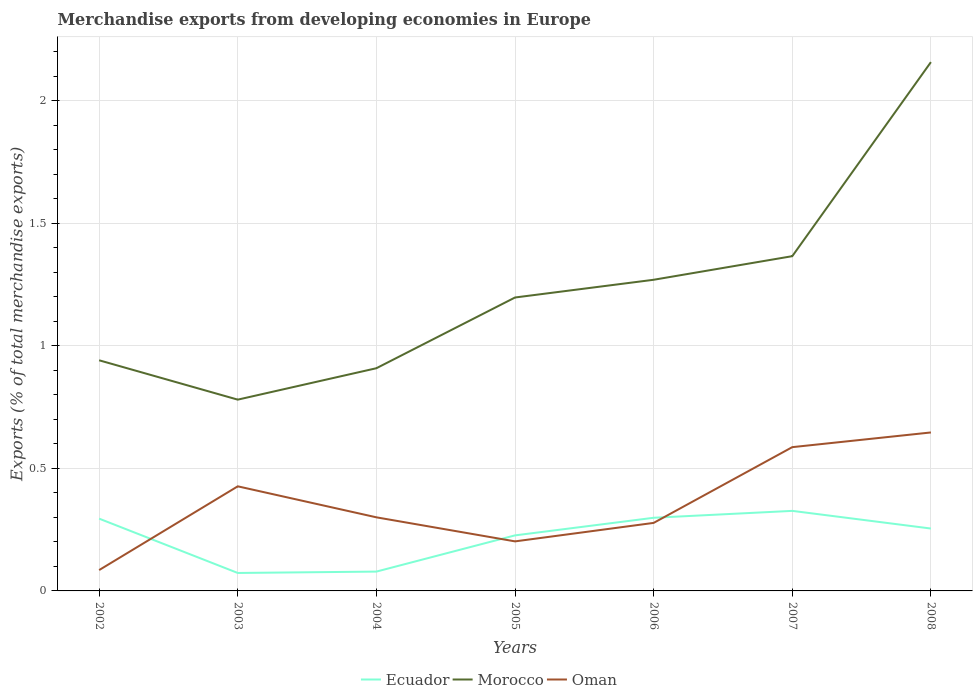Is the number of lines equal to the number of legend labels?
Offer a very short reply. Yes. Across all years, what is the maximum percentage of total merchandise exports in Morocco?
Give a very brief answer. 0.78. In which year was the percentage of total merchandise exports in Oman maximum?
Keep it short and to the point. 2002. What is the total percentage of total merchandise exports in Oman in the graph?
Offer a very short reply. -0.16. What is the difference between the highest and the second highest percentage of total merchandise exports in Morocco?
Make the answer very short. 1.38. What is the difference between the highest and the lowest percentage of total merchandise exports in Morocco?
Give a very brief answer. 3. Is the percentage of total merchandise exports in Ecuador strictly greater than the percentage of total merchandise exports in Morocco over the years?
Provide a short and direct response. Yes. Does the graph contain any zero values?
Offer a terse response. No. Does the graph contain grids?
Your answer should be very brief. Yes. How many legend labels are there?
Make the answer very short. 3. How are the legend labels stacked?
Offer a very short reply. Horizontal. What is the title of the graph?
Provide a short and direct response. Merchandise exports from developing economies in Europe. Does "Libya" appear as one of the legend labels in the graph?
Offer a very short reply. No. What is the label or title of the Y-axis?
Provide a short and direct response. Exports (% of total merchandise exports). What is the Exports (% of total merchandise exports) in Ecuador in 2002?
Provide a short and direct response. 0.3. What is the Exports (% of total merchandise exports) of Morocco in 2002?
Provide a short and direct response. 0.94. What is the Exports (% of total merchandise exports) in Oman in 2002?
Ensure brevity in your answer.  0.09. What is the Exports (% of total merchandise exports) in Ecuador in 2003?
Provide a succinct answer. 0.07. What is the Exports (% of total merchandise exports) in Morocco in 2003?
Your answer should be compact. 0.78. What is the Exports (% of total merchandise exports) in Oman in 2003?
Keep it short and to the point. 0.43. What is the Exports (% of total merchandise exports) of Ecuador in 2004?
Keep it short and to the point. 0.08. What is the Exports (% of total merchandise exports) in Morocco in 2004?
Provide a short and direct response. 0.91. What is the Exports (% of total merchandise exports) of Oman in 2004?
Offer a terse response. 0.3. What is the Exports (% of total merchandise exports) in Ecuador in 2005?
Provide a short and direct response. 0.23. What is the Exports (% of total merchandise exports) of Morocco in 2005?
Make the answer very short. 1.2. What is the Exports (% of total merchandise exports) in Oman in 2005?
Your response must be concise. 0.2. What is the Exports (% of total merchandise exports) of Ecuador in 2006?
Keep it short and to the point. 0.3. What is the Exports (% of total merchandise exports) in Morocco in 2006?
Provide a short and direct response. 1.27. What is the Exports (% of total merchandise exports) in Oman in 2006?
Make the answer very short. 0.28. What is the Exports (% of total merchandise exports) of Ecuador in 2007?
Make the answer very short. 0.33. What is the Exports (% of total merchandise exports) of Morocco in 2007?
Keep it short and to the point. 1.37. What is the Exports (% of total merchandise exports) of Oman in 2007?
Ensure brevity in your answer.  0.59. What is the Exports (% of total merchandise exports) in Ecuador in 2008?
Offer a very short reply. 0.25. What is the Exports (% of total merchandise exports) of Morocco in 2008?
Offer a very short reply. 2.16. What is the Exports (% of total merchandise exports) of Oman in 2008?
Give a very brief answer. 0.65. Across all years, what is the maximum Exports (% of total merchandise exports) in Ecuador?
Offer a very short reply. 0.33. Across all years, what is the maximum Exports (% of total merchandise exports) in Morocco?
Ensure brevity in your answer.  2.16. Across all years, what is the maximum Exports (% of total merchandise exports) in Oman?
Offer a terse response. 0.65. Across all years, what is the minimum Exports (% of total merchandise exports) of Ecuador?
Ensure brevity in your answer.  0.07. Across all years, what is the minimum Exports (% of total merchandise exports) in Morocco?
Give a very brief answer. 0.78. Across all years, what is the minimum Exports (% of total merchandise exports) of Oman?
Your answer should be compact. 0.09. What is the total Exports (% of total merchandise exports) of Ecuador in the graph?
Provide a succinct answer. 1.55. What is the total Exports (% of total merchandise exports) of Morocco in the graph?
Offer a terse response. 8.62. What is the total Exports (% of total merchandise exports) of Oman in the graph?
Provide a short and direct response. 2.53. What is the difference between the Exports (% of total merchandise exports) of Ecuador in 2002 and that in 2003?
Offer a very short reply. 0.22. What is the difference between the Exports (% of total merchandise exports) in Morocco in 2002 and that in 2003?
Provide a succinct answer. 0.16. What is the difference between the Exports (% of total merchandise exports) in Oman in 2002 and that in 2003?
Keep it short and to the point. -0.34. What is the difference between the Exports (% of total merchandise exports) of Ecuador in 2002 and that in 2004?
Ensure brevity in your answer.  0.22. What is the difference between the Exports (% of total merchandise exports) in Morocco in 2002 and that in 2004?
Make the answer very short. 0.03. What is the difference between the Exports (% of total merchandise exports) of Oman in 2002 and that in 2004?
Your response must be concise. -0.22. What is the difference between the Exports (% of total merchandise exports) in Ecuador in 2002 and that in 2005?
Provide a short and direct response. 0.07. What is the difference between the Exports (% of total merchandise exports) of Morocco in 2002 and that in 2005?
Provide a short and direct response. -0.26. What is the difference between the Exports (% of total merchandise exports) of Oman in 2002 and that in 2005?
Offer a terse response. -0.12. What is the difference between the Exports (% of total merchandise exports) of Ecuador in 2002 and that in 2006?
Give a very brief answer. -0. What is the difference between the Exports (% of total merchandise exports) in Morocco in 2002 and that in 2006?
Make the answer very short. -0.33. What is the difference between the Exports (% of total merchandise exports) of Oman in 2002 and that in 2006?
Ensure brevity in your answer.  -0.19. What is the difference between the Exports (% of total merchandise exports) of Ecuador in 2002 and that in 2007?
Offer a very short reply. -0.03. What is the difference between the Exports (% of total merchandise exports) in Morocco in 2002 and that in 2007?
Make the answer very short. -0.42. What is the difference between the Exports (% of total merchandise exports) in Oman in 2002 and that in 2007?
Keep it short and to the point. -0.5. What is the difference between the Exports (% of total merchandise exports) of Ecuador in 2002 and that in 2008?
Ensure brevity in your answer.  0.04. What is the difference between the Exports (% of total merchandise exports) of Morocco in 2002 and that in 2008?
Your response must be concise. -1.22. What is the difference between the Exports (% of total merchandise exports) in Oman in 2002 and that in 2008?
Your answer should be very brief. -0.56. What is the difference between the Exports (% of total merchandise exports) in Ecuador in 2003 and that in 2004?
Keep it short and to the point. -0.01. What is the difference between the Exports (% of total merchandise exports) of Morocco in 2003 and that in 2004?
Make the answer very short. -0.13. What is the difference between the Exports (% of total merchandise exports) in Oman in 2003 and that in 2004?
Make the answer very short. 0.13. What is the difference between the Exports (% of total merchandise exports) of Ecuador in 2003 and that in 2005?
Give a very brief answer. -0.15. What is the difference between the Exports (% of total merchandise exports) in Morocco in 2003 and that in 2005?
Keep it short and to the point. -0.42. What is the difference between the Exports (% of total merchandise exports) in Oman in 2003 and that in 2005?
Make the answer very short. 0.22. What is the difference between the Exports (% of total merchandise exports) of Ecuador in 2003 and that in 2006?
Provide a short and direct response. -0.23. What is the difference between the Exports (% of total merchandise exports) in Morocco in 2003 and that in 2006?
Provide a succinct answer. -0.49. What is the difference between the Exports (% of total merchandise exports) of Oman in 2003 and that in 2006?
Provide a succinct answer. 0.15. What is the difference between the Exports (% of total merchandise exports) of Ecuador in 2003 and that in 2007?
Offer a very short reply. -0.25. What is the difference between the Exports (% of total merchandise exports) in Morocco in 2003 and that in 2007?
Ensure brevity in your answer.  -0.59. What is the difference between the Exports (% of total merchandise exports) of Oman in 2003 and that in 2007?
Keep it short and to the point. -0.16. What is the difference between the Exports (% of total merchandise exports) of Ecuador in 2003 and that in 2008?
Your answer should be very brief. -0.18. What is the difference between the Exports (% of total merchandise exports) of Morocco in 2003 and that in 2008?
Offer a very short reply. -1.38. What is the difference between the Exports (% of total merchandise exports) of Oman in 2003 and that in 2008?
Ensure brevity in your answer.  -0.22. What is the difference between the Exports (% of total merchandise exports) in Ecuador in 2004 and that in 2005?
Ensure brevity in your answer.  -0.15. What is the difference between the Exports (% of total merchandise exports) of Morocco in 2004 and that in 2005?
Offer a terse response. -0.29. What is the difference between the Exports (% of total merchandise exports) in Oman in 2004 and that in 2005?
Your response must be concise. 0.1. What is the difference between the Exports (% of total merchandise exports) in Ecuador in 2004 and that in 2006?
Make the answer very short. -0.22. What is the difference between the Exports (% of total merchandise exports) in Morocco in 2004 and that in 2006?
Your answer should be compact. -0.36. What is the difference between the Exports (% of total merchandise exports) in Oman in 2004 and that in 2006?
Keep it short and to the point. 0.02. What is the difference between the Exports (% of total merchandise exports) in Ecuador in 2004 and that in 2007?
Provide a succinct answer. -0.25. What is the difference between the Exports (% of total merchandise exports) of Morocco in 2004 and that in 2007?
Your response must be concise. -0.46. What is the difference between the Exports (% of total merchandise exports) in Oman in 2004 and that in 2007?
Make the answer very short. -0.29. What is the difference between the Exports (% of total merchandise exports) of Ecuador in 2004 and that in 2008?
Your answer should be very brief. -0.18. What is the difference between the Exports (% of total merchandise exports) of Morocco in 2004 and that in 2008?
Give a very brief answer. -1.25. What is the difference between the Exports (% of total merchandise exports) in Oman in 2004 and that in 2008?
Keep it short and to the point. -0.35. What is the difference between the Exports (% of total merchandise exports) of Ecuador in 2005 and that in 2006?
Your answer should be compact. -0.07. What is the difference between the Exports (% of total merchandise exports) in Morocco in 2005 and that in 2006?
Make the answer very short. -0.07. What is the difference between the Exports (% of total merchandise exports) in Oman in 2005 and that in 2006?
Offer a terse response. -0.08. What is the difference between the Exports (% of total merchandise exports) in Ecuador in 2005 and that in 2007?
Your response must be concise. -0.1. What is the difference between the Exports (% of total merchandise exports) of Morocco in 2005 and that in 2007?
Provide a short and direct response. -0.17. What is the difference between the Exports (% of total merchandise exports) of Oman in 2005 and that in 2007?
Keep it short and to the point. -0.38. What is the difference between the Exports (% of total merchandise exports) of Ecuador in 2005 and that in 2008?
Provide a short and direct response. -0.03. What is the difference between the Exports (% of total merchandise exports) in Morocco in 2005 and that in 2008?
Make the answer very short. -0.96. What is the difference between the Exports (% of total merchandise exports) in Oman in 2005 and that in 2008?
Ensure brevity in your answer.  -0.44. What is the difference between the Exports (% of total merchandise exports) in Ecuador in 2006 and that in 2007?
Provide a succinct answer. -0.03. What is the difference between the Exports (% of total merchandise exports) of Morocco in 2006 and that in 2007?
Offer a very short reply. -0.1. What is the difference between the Exports (% of total merchandise exports) in Oman in 2006 and that in 2007?
Ensure brevity in your answer.  -0.31. What is the difference between the Exports (% of total merchandise exports) in Ecuador in 2006 and that in 2008?
Provide a succinct answer. 0.04. What is the difference between the Exports (% of total merchandise exports) of Morocco in 2006 and that in 2008?
Your answer should be very brief. -0.89. What is the difference between the Exports (% of total merchandise exports) in Oman in 2006 and that in 2008?
Provide a succinct answer. -0.37. What is the difference between the Exports (% of total merchandise exports) of Ecuador in 2007 and that in 2008?
Your answer should be compact. 0.07. What is the difference between the Exports (% of total merchandise exports) in Morocco in 2007 and that in 2008?
Offer a terse response. -0.79. What is the difference between the Exports (% of total merchandise exports) in Oman in 2007 and that in 2008?
Your answer should be compact. -0.06. What is the difference between the Exports (% of total merchandise exports) in Ecuador in 2002 and the Exports (% of total merchandise exports) in Morocco in 2003?
Offer a terse response. -0.49. What is the difference between the Exports (% of total merchandise exports) of Ecuador in 2002 and the Exports (% of total merchandise exports) of Oman in 2003?
Offer a terse response. -0.13. What is the difference between the Exports (% of total merchandise exports) in Morocco in 2002 and the Exports (% of total merchandise exports) in Oman in 2003?
Your answer should be compact. 0.51. What is the difference between the Exports (% of total merchandise exports) in Ecuador in 2002 and the Exports (% of total merchandise exports) in Morocco in 2004?
Provide a short and direct response. -0.61. What is the difference between the Exports (% of total merchandise exports) of Ecuador in 2002 and the Exports (% of total merchandise exports) of Oman in 2004?
Your answer should be compact. -0.01. What is the difference between the Exports (% of total merchandise exports) of Morocco in 2002 and the Exports (% of total merchandise exports) of Oman in 2004?
Give a very brief answer. 0.64. What is the difference between the Exports (% of total merchandise exports) of Ecuador in 2002 and the Exports (% of total merchandise exports) of Morocco in 2005?
Ensure brevity in your answer.  -0.9. What is the difference between the Exports (% of total merchandise exports) of Ecuador in 2002 and the Exports (% of total merchandise exports) of Oman in 2005?
Keep it short and to the point. 0.09. What is the difference between the Exports (% of total merchandise exports) in Morocco in 2002 and the Exports (% of total merchandise exports) in Oman in 2005?
Offer a terse response. 0.74. What is the difference between the Exports (% of total merchandise exports) in Ecuador in 2002 and the Exports (% of total merchandise exports) in Morocco in 2006?
Provide a succinct answer. -0.98. What is the difference between the Exports (% of total merchandise exports) of Ecuador in 2002 and the Exports (% of total merchandise exports) of Oman in 2006?
Your response must be concise. 0.02. What is the difference between the Exports (% of total merchandise exports) in Morocco in 2002 and the Exports (% of total merchandise exports) in Oman in 2006?
Your answer should be very brief. 0.66. What is the difference between the Exports (% of total merchandise exports) in Ecuador in 2002 and the Exports (% of total merchandise exports) in Morocco in 2007?
Give a very brief answer. -1.07. What is the difference between the Exports (% of total merchandise exports) of Ecuador in 2002 and the Exports (% of total merchandise exports) of Oman in 2007?
Keep it short and to the point. -0.29. What is the difference between the Exports (% of total merchandise exports) in Morocco in 2002 and the Exports (% of total merchandise exports) in Oman in 2007?
Make the answer very short. 0.35. What is the difference between the Exports (% of total merchandise exports) of Ecuador in 2002 and the Exports (% of total merchandise exports) of Morocco in 2008?
Give a very brief answer. -1.86. What is the difference between the Exports (% of total merchandise exports) in Ecuador in 2002 and the Exports (% of total merchandise exports) in Oman in 2008?
Your response must be concise. -0.35. What is the difference between the Exports (% of total merchandise exports) of Morocco in 2002 and the Exports (% of total merchandise exports) of Oman in 2008?
Provide a succinct answer. 0.29. What is the difference between the Exports (% of total merchandise exports) in Ecuador in 2003 and the Exports (% of total merchandise exports) in Morocco in 2004?
Offer a terse response. -0.84. What is the difference between the Exports (% of total merchandise exports) in Ecuador in 2003 and the Exports (% of total merchandise exports) in Oman in 2004?
Provide a succinct answer. -0.23. What is the difference between the Exports (% of total merchandise exports) in Morocco in 2003 and the Exports (% of total merchandise exports) in Oman in 2004?
Make the answer very short. 0.48. What is the difference between the Exports (% of total merchandise exports) of Ecuador in 2003 and the Exports (% of total merchandise exports) of Morocco in 2005?
Give a very brief answer. -1.12. What is the difference between the Exports (% of total merchandise exports) of Ecuador in 2003 and the Exports (% of total merchandise exports) of Oman in 2005?
Your response must be concise. -0.13. What is the difference between the Exports (% of total merchandise exports) of Morocco in 2003 and the Exports (% of total merchandise exports) of Oman in 2005?
Make the answer very short. 0.58. What is the difference between the Exports (% of total merchandise exports) of Ecuador in 2003 and the Exports (% of total merchandise exports) of Morocco in 2006?
Give a very brief answer. -1.2. What is the difference between the Exports (% of total merchandise exports) of Ecuador in 2003 and the Exports (% of total merchandise exports) of Oman in 2006?
Ensure brevity in your answer.  -0.2. What is the difference between the Exports (% of total merchandise exports) in Morocco in 2003 and the Exports (% of total merchandise exports) in Oman in 2006?
Provide a short and direct response. 0.5. What is the difference between the Exports (% of total merchandise exports) of Ecuador in 2003 and the Exports (% of total merchandise exports) of Morocco in 2007?
Your answer should be compact. -1.29. What is the difference between the Exports (% of total merchandise exports) of Ecuador in 2003 and the Exports (% of total merchandise exports) of Oman in 2007?
Your answer should be very brief. -0.51. What is the difference between the Exports (% of total merchandise exports) of Morocco in 2003 and the Exports (% of total merchandise exports) of Oman in 2007?
Ensure brevity in your answer.  0.19. What is the difference between the Exports (% of total merchandise exports) in Ecuador in 2003 and the Exports (% of total merchandise exports) in Morocco in 2008?
Give a very brief answer. -2.09. What is the difference between the Exports (% of total merchandise exports) of Ecuador in 2003 and the Exports (% of total merchandise exports) of Oman in 2008?
Your response must be concise. -0.57. What is the difference between the Exports (% of total merchandise exports) of Morocco in 2003 and the Exports (% of total merchandise exports) of Oman in 2008?
Offer a very short reply. 0.13. What is the difference between the Exports (% of total merchandise exports) of Ecuador in 2004 and the Exports (% of total merchandise exports) of Morocco in 2005?
Your response must be concise. -1.12. What is the difference between the Exports (% of total merchandise exports) in Ecuador in 2004 and the Exports (% of total merchandise exports) in Oman in 2005?
Provide a succinct answer. -0.12. What is the difference between the Exports (% of total merchandise exports) of Morocco in 2004 and the Exports (% of total merchandise exports) of Oman in 2005?
Provide a succinct answer. 0.71. What is the difference between the Exports (% of total merchandise exports) in Ecuador in 2004 and the Exports (% of total merchandise exports) in Morocco in 2006?
Make the answer very short. -1.19. What is the difference between the Exports (% of total merchandise exports) in Ecuador in 2004 and the Exports (% of total merchandise exports) in Oman in 2006?
Provide a short and direct response. -0.2. What is the difference between the Exports (% of total merchandise exports) in Morocco in 2004 and the Exports (% of total merchandise exports) in Oman in 2006?
Make the answer very short. 0.63. What is the difference between the Exports (% of total merchandise exports) of Ecuador in 2004 and the Exports (% of total merchandise exports) of Morocco in 2007?
Make the answer very short. -1.29. What is the difference between the Exports (% of total merchandise exports) in Ecuador in 2004 and the Exports (% of total merchandise exports) in Oman in 2007?
Your response must be concise. -0.51. What is the difference between the Exports (% of total merchandise exports) in Morocco in 2004 and the Exports (% of total merchandise exports) in Oman in 2007?
Provide a succinct answer. 0.32. What is the difference between the Exports (% of total merchandise exports) of Ecuador in 2004 and the Exports (% of total merchandise exports) of Morocco in 2008?
Your response must be concise. -2.08. What is the difference between the Exports (% of total merchandise exports) in Ecuador in 2004 and the Exports (% of total merchandise exports) in Oman in 2008?
Make the answer very short. -0.57. What is the difference between the Exports (% of total merchandise exports) in Morocco in 2004 and the Exports (% of total merchandise exports) in Oman in 2008?
Provide a succinct answer. 0.26. What is the difference between the Exports (% of total merchandise exports) of Ecuador in 2005 and the Exports (% of total merchandise exports) of Morocco in 2006?
Provide a short and direct response. -1.04. What is the difference between the Exports (% of total merchandise exports) of Ecuador in 2005 and the Exports (% of total merchandise exports) of Oman in 2006?
Provide a short and direct response. -0.05. What is the difference between the Exports (% of total merchandise exports) of Morocco in 2005 and the Exports (% of total merchandise exports) of Oman in 2006?
Provide a short and direct response. 0.92. What is the difference between the Exports (% of total merchandise exports) of Ecuador in 2005 and the Exports (% of total merchandise exports) of Morocco in 2007?
Your response must be concise. -1.14. What is the difference between the Exports (% of total merchandise exports) in Ecuador in 2005 and the Exports (% of total merchandise exports) in Oman in 2007?
Offer a terse response. -0.36. What is the difference between the Exports (% of total merchandise exports) in Morocco in 2005 and the Exports (% of total merchandise exports) in Oman in 2007?
Make the answer very short. 0.61. What is the difference between the Exports (% of total merchandise exports) of Ecuador in 2005 and the Exports (% of total merchandise exports) of Morocco in 2008?
Offer a terse response. -1.93. What is the difference between the Exports (% of total merchandise exports) of Ecuador in 2005 and the Exports (% of total merchandise exports) of Oman in 2008?
Give a very brief answer. -0.42. What is the difference between the Exports (% of total merchandise exports) in Morocco in 2005 and the Exports (% of total merchandise exports) in Oman in 2008?
Your answer should be very brief. 0.55. What is the difference between the Exports (% of total merchandise exports) of Ecuador in 2006 and the Exports (% of total merchandise exports) of Morocco in 2007?
Your response must be concise. -1.07. What is the difference between the Exports (% of total merchandise exports) in Ecuador in 2006 and the Exports (% of total merchandise exports) in Oman in 2007?
Offer a very short reply. -0.29. What is the difference between the Exports (% of total merchandise exports) in Morocco in 2006 and the Exports (% of total merchandise exports) in Oman in 2007?
Offer a terse response. 0.68. What is the difference between the Exports (% of total merchandise exports) in Ecuador in 2006 and the Exports (% of total merchandise exports) in Morocco in 2008?
Offer a terse response. -1.86. What is the difference between the Exports (% of total merchandise exports) of Ecuador in 2006 and the Exports (% of total merchandise exports) of Oman in 2008?
Give a very brief answer. -0.35. What is the difference between the Exports (% of total merchandise exports) in Morocco in 2006 and the Exports (% of total merchandise exports) in Oman in 2008?
Provide a succinct answer. 0.62. What is the difference between the Exports (% of total merchandise exports) of Ecuador in 2007 and the Exports (% of total merchandise exports) of Morocco in 2008?
Offer a very short reply. -1.83. What is the difference between the Exports (% of total merchandise exports) of Ecuador in 2007 and the Exports (% of total merchandise exports) of Oman in 2008?
Your response must be concise. -0.32. What is the difference between the Exports (% of total merchandise exports) in Morocco in 2007 and the Exports (% of total merchandise exports) in Oman in 2008?
Keep it short and to the point. 0.72. What is the average Exports (% of total merchandise exports) of Ecuador per year?
Ensure brevity in your answer.  0.22. What is the average Exports (% of total merchandise exports) of Morocco per year?
Offer a very short reply. 1.23. What is the average Exports (% of total merchandise exports) of Oman per year?
Offer a terse response. 0.36. In the year 2002, what is the difference between the Exports (% of total merchandise exports) in Ecuador and Exports (% of total merchandise exports) in Morocco?
Your answer should be very brief. -0.65. In the year 2002, what is the difference between the Exports (% of total merchandise exports) of Ecuador and Exports (% of total merchandise exports) of Oman?
Offer a very short reply. 0.21. In the year 2002, what is the difference between the Exports (% of total merchandise exports) of Morocco and Exports (% of total merchandise exports) of Oman?
Provide a short and direct response. 0.86. In the year 2003, what is the difference between the Exports (% of total merchandise exports) in Ecuador and Exports (% of total merchandise exports) in Morocco?
Offer a very short reply. -0.71. In the year 2003, what is the difference between the Exports (% of total merchandise exports) of Ecuador and Exports (% of total merchandise exports) of Oman?
Ensure brevity in your answer.  -0.35. In the year 2003, what is the difference between the Exports (% of total merchandise exports) of Morocco and Exports (% of total merchandise exports) of Oman?
Offer a terse response. 0.35. In the year 2004, what is the difference between the Exports (% of total merchandise exports) of Ecuador and Exports (% of total merchandise exports) of Morocco?
Your answer should be compact. -0.83. In the year 2004, what is the difference between the Exports (% of total merchandise exports) of Ecuador and Exports (% of total merchandise exports) of Oman?
Offer a terse response. -0.22. In the year 2004, what is the difference between the Exports (% of total merchandise exports) in Morocco and Exports (% of total merchandise exports) in Oman?
Keep it short and to the point. 0.61. In the year 2005, what is the difference between the Exports (% of total merchandise exports) in Ecuador and Exports (% of total merchandise exports) in Morocco?
Provide a short and direct response. -0.97. In the year 2005, what is the difference between the Exports (% of total merchandise exports) in Ecuador and Exports (% of total merchandise exports) in Oman?
Make the answer very short. 0.02. In the year 2006, what is the difference between the Exports (% of total merchandise exports) of Ecuador and Exports (% of total merchandise exports) of Morocco?
Provide a short and direct response. -0.97. In the year 2006, what is the difference between the Exports (% of total merchandise exports) in Ecuador and Exports (% of total merchandise exports) in Oman?
Ensure brevity in your answer.  0.02. In the year 2007, what is the difference between the Exports (% of total merchandise exports) of Ecuador and Exports (% of total merchandise exports) of Morocco?
Give a very brief answer. -1.04. In the year 2007, what is the difference between the Exports (% of total merchandise exports) of Ecuador and Exports (% of total merchandise exports) of Oman?
Keep it short and to the point. -0.26. In the year 2007, what is the difference between the Exports (% of total merchandise exports) of Morocco and Exports (% of total merchandise exports) of Oman?
Make the answer very short. 0.78. In the year 2008, what is the difference between the Exports (% of total merchandise exports) of Ecuador and Exports (% of total merchandise exports) of Morocco?
Your answer should be compact. -1.9. In the year 2008, what is the difference between the Exports (% of total merchandise exports) in Ecuador and Exports (% of total merchandise exports) in Oman?
Your answer should be compact. -0.39. In the year 2008, what is the difference between the Exports (% of total merchandise exports) of Morocco and Exports (% of total merchandise exports) of Oman?
Ensure brevity in your answer.  1.51. What is the ratio of the Exports (% of total merchandise exports) of Ecuador in 2002 to that in 2003?
Offer a terse response. 4.03. What is the ratio of the Exports (% of total merchandise exports) in Morocco in 2002 to that in 2003?
Your answer should be very brief. 1.21. What is the ratio of the Exports (% of total merchandise exports) in Oman in 2002 to that in 2003?
Your answer should be compact. 0.2. What is the ratio of the Exports (% of total merchandise exports) of Ecuador in 2002 to that in 2004?
Your answer should be very brief. 3.74. What is the ratio of the Exports (% of total merchandise exports) of Morocco in 2002 to that in 2004?
Your answer should be compact. 1.04. What is the ratio of the Exports (% of total merchandise exports) in Oman in 2002 to that in 2004?
Offer a terse response. 0.28. What is the ratio of the Exports (% of total merchandise exports) of Ecuador in 2002 to that in 2005?
Your answer should be very brief. 1.3. What is the ratio of the Exports (% of total merchandise exports) in Morocco in 2002 to that in 2005?
Provide a short and direct response. 0.79. What is the ratio of the Exports (% of total merchandise exports) in Oman in 2002 to that in 2005?
Provide a short and direct response. 0.42. What is the ratio of the Exports (% of total merchandise exports) of Ecuador in 2002 to that in 2006?
Offer a terse response. 0.99. What is the ratio of the Exports (% of total merchandise exports) in Morocco in 2002 to that in 2006?
Provide a succinct answer. 0.74. What is the ratio of the Exports (% of total merchandise exports) in Oman in 2002 to that in 2006?
Ensure brevity in your answer.  0.31. What is the ratio of the Exports (% of total merchandise exports) in Ecuador in 2002 to that in 2007?
Keep it short and to the point. 0.9. What is the ratio of the Exports (% of total merchandise exports) in Morocco in 2002 to that in 2007?
Your answer should be compact. 0.69. What is the ratio of the Exports (% of total merchandise exports) in Oman in 2002 to that in 2007?
Your answer should be compact. 0.14. What is the ratio of the Exports (% of total merchandise exports) in Ecuador in 2002 to that in 2008?
Your answer should be compact. 1.16. What is the ratio of the Exports (% of total merchandise exports) in Morocco in 2002 to that in 2008?
Offer a terse response. 0.44. What is the ratio of the Exports (% of total merchandise exports) in Oman in 2002 to that in 2008?
Your response must be concise. 0.13. What is the ratio of the Exports (% of total merchandise exports) of Ecuador in 2003 to that in 2004?
Your response must be concise. 0.93. What is the ratio of the Exports (% of total merchandise exports) in Morocco in 2003 to that in 2004?
Provide a succinct answer. 0.86. What is the ratio of the Exports (% of total merchandise exports) in Oman in 2003 to that in 2004?
Give a very brief answer. 1.42. What is the ratio of the Exports (% of total merchandise exports) of Ecuador in 2003 to that in 2005?
Your response must be concise. 0.32. What is the ratio of the Exports (% of total merchandise exports) of Morocco in 2003 to that in 2005?
Your answer should be very brief. 0.65. What is the ratio of the Exports (% of total merchandise exports) in Oman in 2003 to that in 2005?
Offer a very short reply. 2.11. What is the ratio of the Exports (% of total merchandise exports) in Ecuador in 2003 to that in 2006?
Your answer should be compact. 0.25. What is the ratio of the Exports (% of total merchandise exports) in Morocco in 2003 to that in 2006?
Your answer should be very brief. 0.61. What is the ratio of the Exports (% of total merchandise exports) in Oman in 2003 to that in 2006?
Offer a terse response. 1.54. What is the ratio of the Exports (% of total merchandise exports) of Ecuador in 2003 to that in 2007?
Provide a succinct answer. 0.22. What is the ratio of the Exports (% of total merchandise exports) of Oman in 2003 to that in 2007?
Your answer should be very brief. 0.73. What is the ratio of the Exports (% of total merchandise exports) in Ecuador in 2003 to that in 2008?
Keep it short and to the point. 0.29. What is the ratio of the Exports (% of total merchandise exports) of Morocco in 2003 to that in 2008?
Keep it short and to the point. 0.36. What is the ratio of the Exports (% of total merchandise exports) of Oman in 2003 to that in 2008?
Make the answer very short. 0.66. What is the ratio of the Exports (% of total merchandise exports) in Ecuador in 2004 to that in 2005?
Offer a terse response. 0.35. What is the ratio of the Exports (% of total merchandise exports) of Morocco in 2004 to that in 2005?
Keep it short and to the point. 0.76. What is the ratio of the Exports (% of total merchandise exports) in Oman in 2004 to that in 2005?
Your answer should be very brief. 1.49. What is the ratio of the Exports (% of total merchandise exports) of Ecuador in 2004 to that in 2006?
Offer a very short reply. 0.26. What is the ratio of the Exports (% of total merchandise exports) of Morocco in 2004 to that in 2006?
Ensure brevity in your answer.  0.72. What is the ratio of the Exports (% of total merchandise exports) of Oman in 2004 to that in 2006?
Your response must be concise. 1.08. What is the ratio of the Exports (% of total merchandise exports) in Ecuador in 2004 to that in 2007?
Your response must be concise. 0.24. What is the ratio of the Exports (% of total merchandise exports) in Morocco in 2004 to that in 2007?
Provide a short and direct response. 0.67. What is the ratio of the Exports (% of total merchandise exports) in Oman in 2004 to that in 2007?
Your answer should be compact. 0.51. What is the ratio of the Exports (% of total merchandise exports) in Ecuador in 2004 to that in 2008?
Your response must be concise. 0.31. What is the ratio of the Exports (% of total merchandise exports) of Morocco in 2004 to that in 2008?
Your response must be concise. 0.42. What is the ratio of the Exports (% of total merchandise exports) in Oman in 2004 to that in 2008?
Make the answer very short. 0.46. What is the ratio of the Exports (% of total merchandise exports) of Ecuador in 2005 to that in 2006?
Your response must be concise. 0.76. What is the ratio of the Exports (% of total merchandise exports) of Morocco in 2005 to that in 2006?
Offer a terse response. 0.94. What is the ratio of the Exports (% of total merchandise exports) of Oman in 2005 to that in 2006?
Offer a terse response. 0.73. What is the ratio of the Exports (% of total merchandise exports) in Ecuador in 2005 to that in 2007?
Offer a terse response. 0.69. What is the ratio of the Exports (% of total merchandise exports) in Morocco in 2005 to that in 2007?
Ensure brevity in your answer.  0.88. What is the ratio of the Exports (% of total merchandise exports) of Oman in 2005 to that in 2007?
Give a very brief answer. 0.34. What is the ratio of the Exports (% of total merchandise exports) in Ecuador in 2005 to that in 2008?
Make the answer very short. 0.89. What is the ratio of the Exports (% of total merchandise exports) in Morocco in 2005 to that in 2008?
Offer a terse response. 0.55. What is the ratio of the Exports (% of total merchandise exports) of Oman in 2005 to that in 2008?
Provide a short and direct response. 0.31. What is the ratio of the Exports (% of total merchandise exports) in Ecuador in 2006 to that in 2007?
Provide a succinct answer. 0.91. What is the ratio of the Exports (% of total merchandise exports) in Morocco in 2006 to that in 2007?
Your answer should be compact. 0.93. What is the ratio of the Exports (% of total merchandise exports) of Oman in 2006 to that in 2007?
Ensure brevity in your answer.  0.47. What is the ratio of the Exports (% of total merchandise exports) in Ecuador in 2006 to that in 2008?
Keep it short and to the point. 1.17. What is the ratio of the Exports (% of total merchandise exports) of Morocco in 2006 to that in 2008?
Offer a terse response. 0.59. What is the ratio of the Exports (% of total merchandise exports) of Oman in 2006 to that in 2008?
Your response must be concise. 0.43. What is the ratio of the Exports (% of total merchandise exports) of Ecuador in 2007 to that in 2008?
Provide a short and direct response. 1.28. What is the ratio of the Exports (% of total merchandise exports) of Morocco in 2007 to that in 2008?
Provide a short and direct response. 0.63. What is the ratio of the Exports (% of total merchandise exports) of Oman in 2007 to that in 2008?
Ensure brevity in your answer.  0.91. What is the difference between the highest and the second highest Exports (% of total merchandise exports) of Ecuador?
Keep it short and to the point. 0.03. What is the difference between the highest and the second highest Exports (% of total merchandise exports) in Morocco?
Give a very brief answer. 0.79. What is the difference between the highest and the lowest Exports (% of total merchandise exports) in Ecuador?
Provide a short and direct response. 0.25. What is the difference between the highest and the lowest Exports (% of total merchandise exports) in Morocco?
Keep it short and to the point. 1.38. What is the difference between the highest and the lowest Exports (% of total merchandise exports) in Oman?
Provide a short and direct response. 0.56. 